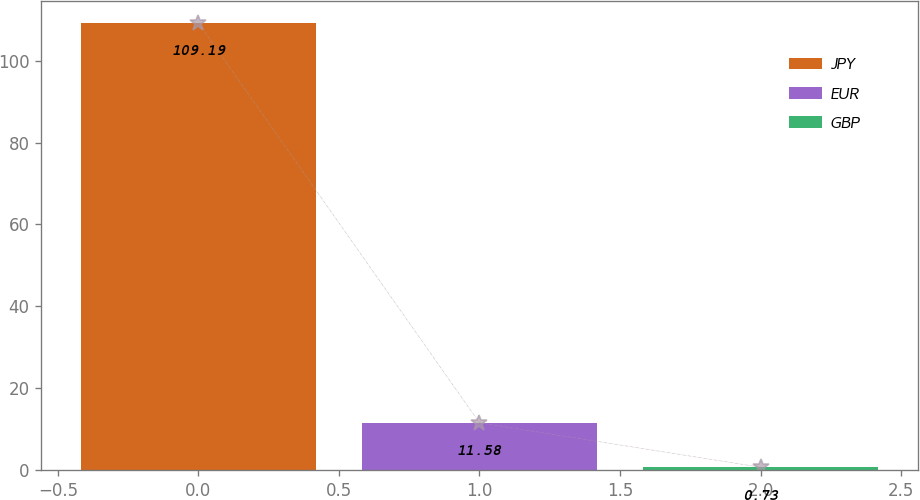Convert chart to OTSL. <chart><loc_0><loc_0><loc_500><loc_500><bar_chart><fcel>JPY<fcel>EUR<fcel>GBP<nl><fcel>109.19<fcel>11.58<fcel>0.73<nl></chart> 